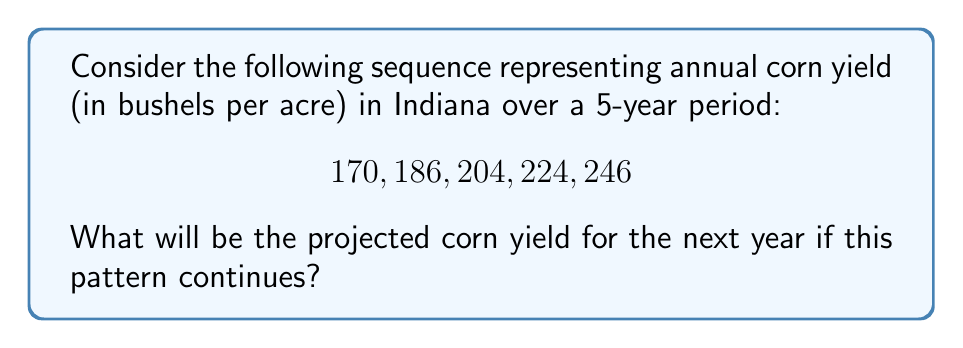Could you help me with this problem? To solve this problem, let's follow these steps:

1) First, we need to determine the pattern in the sequence. Let's calculate the differences between consecutive terms:

   $186 - 170 = 16$
   $204 - 186 = 18$
   $224 - 204 = 20$
   $246 - 224 = 22$

2) We can see that the difference is increasing by 2 each time:

   $16, 18, 20, 22$

3) This suggests that we're dealing with a quadratic sequence.

4) In a quadratic sequence, the second difference is constant. Let's verify:

   $18 - 16 = 2$
   $20 - 18 = 2$
   $22 - 20 = 2$

   Indeed, the second difference is constant (2).

5) For a quadratic sequence of the form $an^2 + bn + c$, the second difference is always $2a$. Here, the second difference is 2, so $a = 1$.

6) Now we can set up a system of equations using the first three terms:

   $170 = c$
   $186 = 1 + b + 170$
   $204 = 4 + 2b + 170$

7) From the second equation:
   $16 = 1 + b$
   $b = 15$

8) We can verify this with the third equation:
   $204 = 4 + 2(15) + 170$
   $204 = 204$ (it checks out)

9) So our sequence follows the formula: $n^2 + 15n + 170$

10) To find the next term, we substitute $n = 6$:

    $6^2 + 15(6) + 170 = 36 + 90 + 170 = 296$

Therefore, the projected corn yield for the next year is 296 bushels per acre.
Answer: 296 bushels per acre 